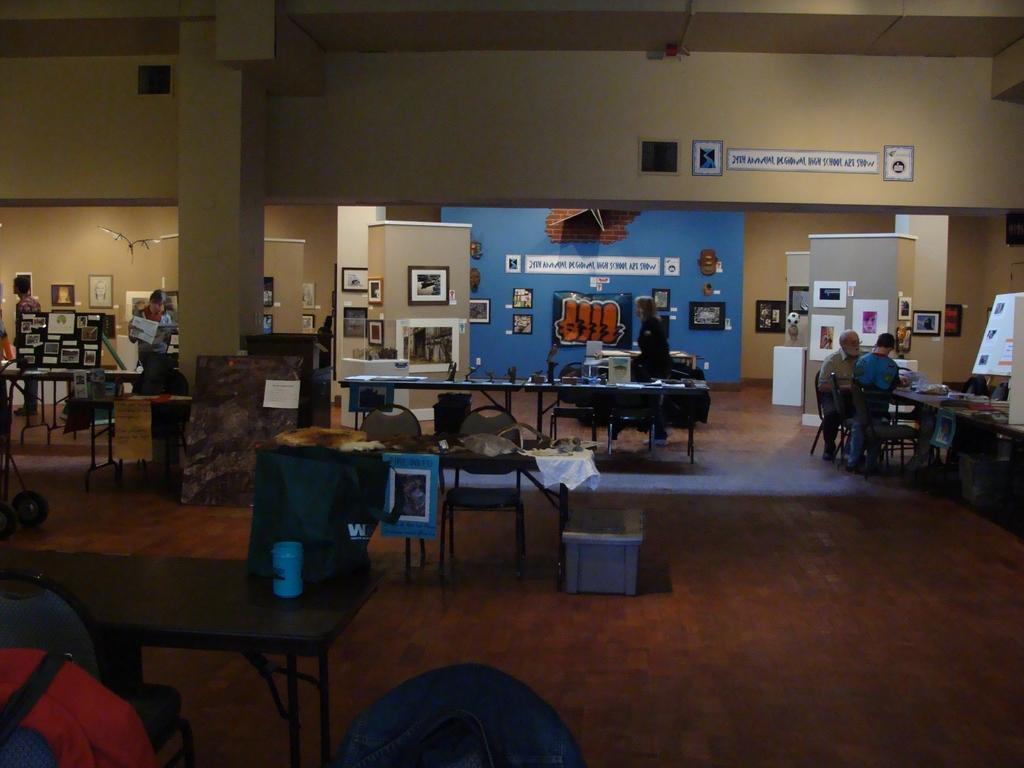Please provide a concise description of this image. In this image, we can see few people ,there are so many tables, chairs ,few items are placed on it. At the back side, we can see photo frames, posters, stickers, board, wall, pillar. 